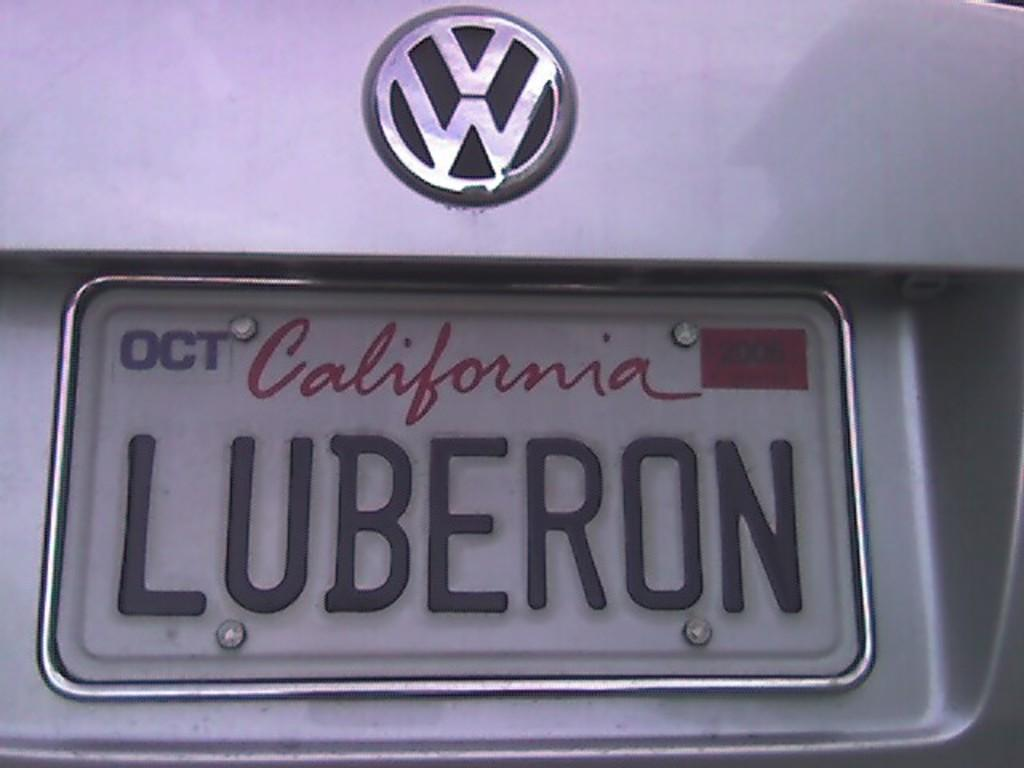<image>
Provide a brief description of the given image. A Californian licence plate on a VW car. 